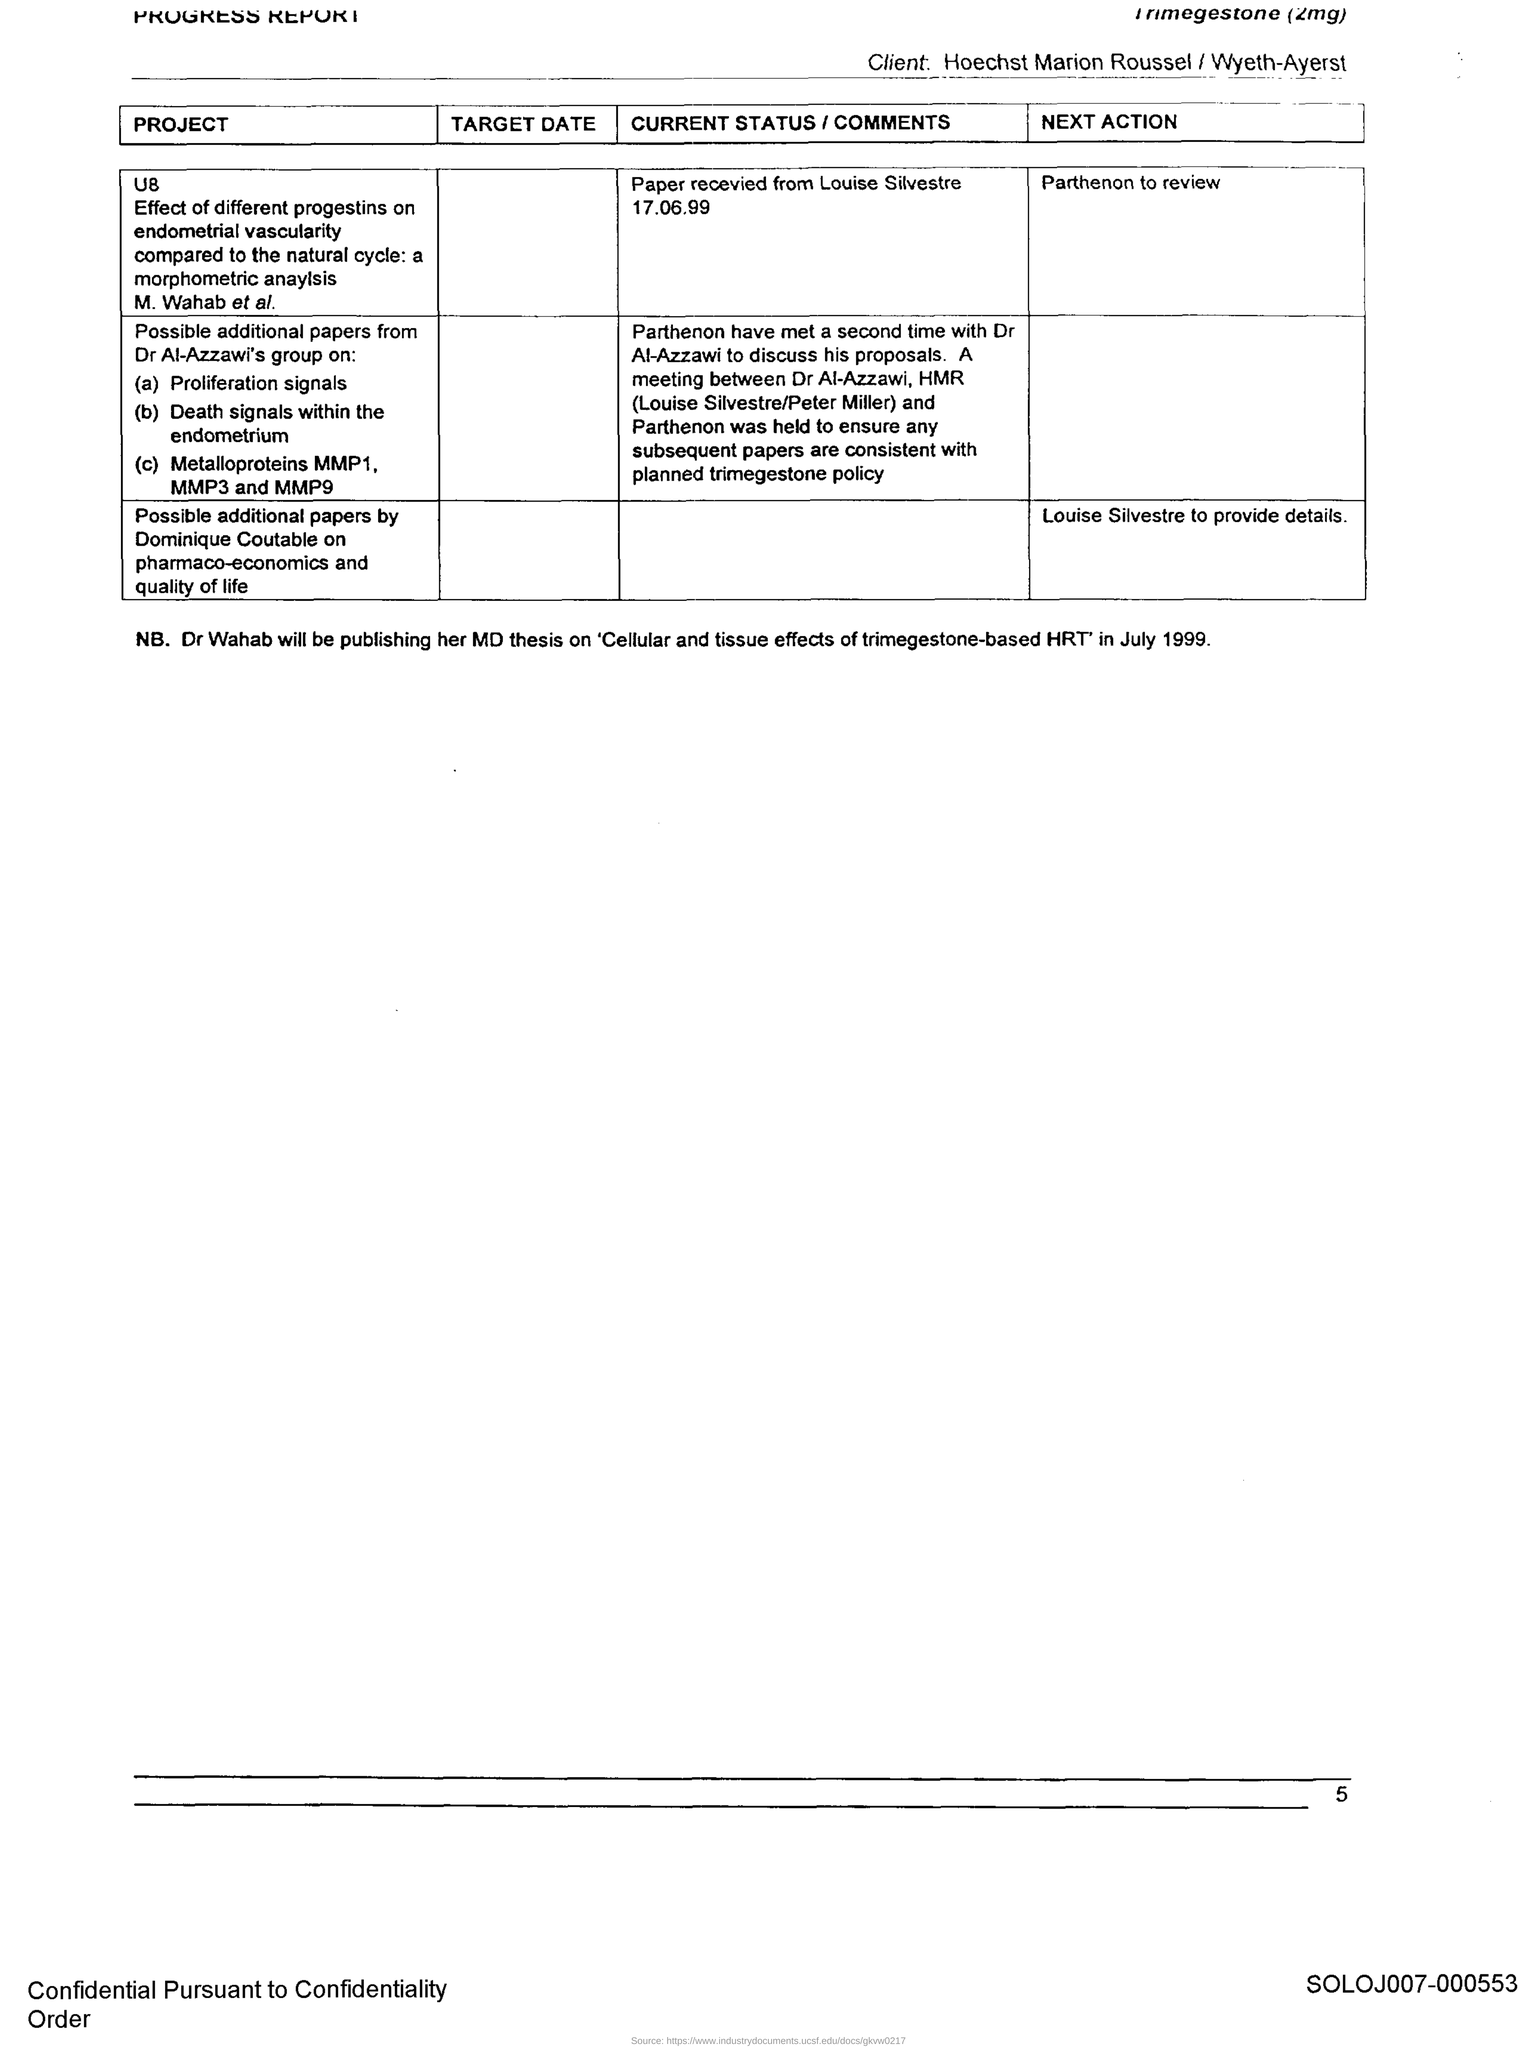Outline some significant characteristics in this image. Dr. Wahab will be publishing a MD thesis titled "Cellular and tissue effects of trimegestone-based HRT" in July 1999. 